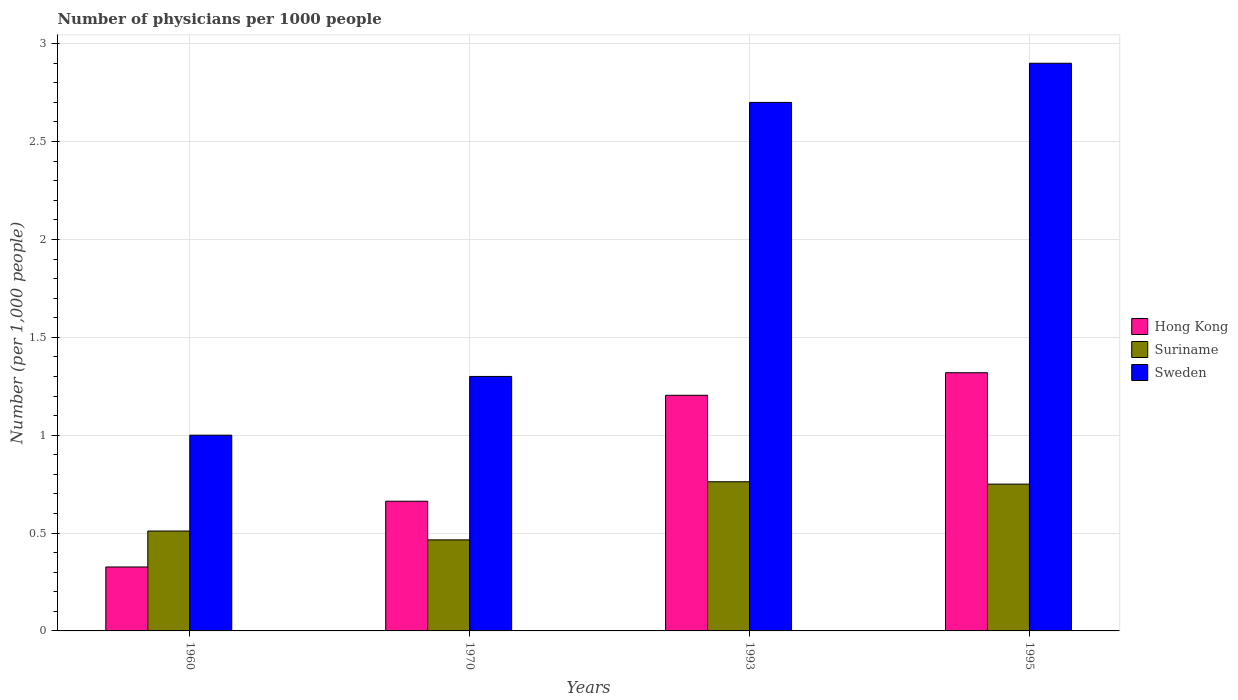How many different coloured bars are there?
Your response must be concise. 3. Are the number of bars on each tick of the X-axis equal?
Keep it short and to the point. Yes. How many bars are there on the 4th tick from the right?
Offer a terse response. 3. What is the number of physicians in Hong Kong in 1995?
Your answer should be compact. 1.32. Across all years, what is the maximum number of physicians in Suriname?
Offer a very short reply. 0.76. Across all years, what is the minimum number of physicians in Suriname?
Your answer should be very brief. 0.47. What is the total number of physicians in Sweden in the graph?
Keep it short and to the point. 7.9. What is the difference between the number of physicians in Hong Kong in 1993 and that in 1995?
Keep it short and to the point. -0.12. What is the difference between the number of physicians in Hong Kong in 1970 and the number of physicians in Sweden in 1960?
Ensure brevity in your answer.  -0.34. What is the average number of physicians in Sweden per year?
Provide a short and direct response. 1.98. In the year 1960, what is the difference between the number of physicians in Sweden and number of physicians in Suriname?
Your response must be concise. 0.49. In how many years, is the number of physicians in Suriname greater than 2.1?
Make the answer very short. 0. What is the ratio of the number of physicians in Hong Kong in 1960 to that in 1993?
Make the answer very short. 0.27. What is the difference between the highest and the second highest number of physicians in Sweden?
Keep it short and to the point. 0.2. What is the difference between the highest and the lowest number of physicians in Hong Kong?
Offer a terse response. 0.99. In how many years, is the number of physicians in Hong Kong greater than the average number of physicians in Hong Kong taken over all years?
Keep it short and to the point. 2. Is the sum of the number of physicians in Suriname in 1970 and 1995 greater than the maximum number of physicians in Hong Kong across all years?
Your answer should be compact. No. What does the 2nd bar from the left in 1993 represents?
Provide a succinct answer. Suriname. What does the 3rd bar from the right in 1970 represents?
Make the answer very short. Hong Kong. Are all the bars in the graph horizontal?
Give a very brief answer. No. Are the values on the major ticks of Y-axis written in scientific E-notation?
Make the answer very short. No. Does the graph contain any zero values?
Your response must be concise. No. Does the graph contain grids?
Offer a terse response. Yes. What is the title of the graph?
Your response must be concise. Number of physicians per 1000 people. Does "Hong Kong" appear as one of the legend labels in the graph?
Give a very brief answer. Yes. What is the label or title of the X-axis?
Offer a terse response. Years. What is the label or title of the Y-axis?
Your response must be concise. Number (per 1,0 people). What is the Number (per 1,000 people) in Hong Kong in 1960?
Provide a short and direct response. 0.33. What is the Number (per 1,000 people) of Suriname in 1960?
Make the answer very short. 0.51. What is the Number (per 1,000 people) of Sweden in 1960?
Offer a very short reply. 1. What is the Number (per 1,000 people) in Hong Kong in 1970?
Your response must be concise. 0.66. What is the Number (per 1,000 people) of Suriname in 1970?
Your answer should be very brief. 0.47. What is the Number (per 1,000 people) of Sweden in 1970?
Offer a very short reply. 1.3. What is the Number (per 1,000 people) in Hong Kong in 1993?
Give a very brief answer. 1.2. What is the Number (per 1,000 people) in Suriname in 1993?
Your response must be concise. 0.76. What is the Number (per 1,000 people) in Sweden in 1993?
Your response must be concise. 2.7. What is the Number (per 1,000 people) of Hong Kong in 1995?
Provide a short and direct response. 1.32. What is the Number (per 1,000 people) of Suriname in 1995?
Your answer should be compact. 0.75. Across all years, what is the maximum Number (per 1,000 people) of Hong Kong?
Give a very brief answer. 1.32. Across all years, what is the maximum Number (per 1,000 people) in Suriname?
Ensure brevity in your answer.  0.76. Across all years, what is the maximum Number (per 1,000 people) of Sweden?
Your answer should be very brief. 2.9. Across all years, what is the minimum Number (per 1,000 people) in Hong Kong?
Your answer should be compact. 0.33. Across all years, what is the minimum Number (per 1,000 people) of Suriname?
Keep it short and to the point. 0.47. What is the total Number (per 1,000 people) of Hong Kong in the graph?
Your answer should be compact. 3.51. What is the total Number (per 1,000 people) of Suriname in the graph?
Provide a short and direct response. 2.49. What is the total Number (per 1,000 people) in Sweden in the graph?
Ensure brevity in your answer.  7.9. What is the difference between the Number (per 1,000 people) in Hong Kong in 1960 and that in 1970?
Make the answer very short. -0.34. What is the difference between the Number (per 1,000 people) of Suriname in 1960 and that in 1970?
Provide a succinct answer. 0.05. What is the difference between the Number (per 1,000 people) in Sweden in 1960 and that in 1970?
Provide a succinct answer. -0.3. What is the difference between the Number (per 1,000 people) in Hong Kong in 1960 and that in 1993?
Give a very brief answer. -0.88. What is the difference between the Number (per 1,000 people) in Suriname in 1960 and that in 1993?
Offer a very short reply. -0.25. What is the difference between the Number (per 1,000 people) in Hong Kong in 1960 and that in 1995?
Offer a very short reply. -0.99. What is the difference between the Number (per 1,000 people) of Suriname in 1960 and that in 1995?
Give a very brief answer. -0.24. What is the difference between the Number (per 1,000 people) of Hong Kong in 1970 and that in 1993?
Ensure brevity in your answer.  -0.54. What is the difference between the Number (per 1,000 people) of Suriname in 1970 and that in 1993?
Provide a short and direct response. -0.3. What is the difference between the Number (per 1,000 people) of Sweden in 1970 and that in 1993?
Give a very brief answer. -1.4. What is the difference between the Number (per 1,000 people) in Hong Kong in 1970 and that in 1995?
Offer a very short reply. -0.66. What is the difference between the Number (per 1,000 people) of Suriname in 1970 and that in 1995?
Your response must be concise. -0.28. What is the difference between the Number (per 1,000 people) of Sweden in 1970 and that in 1995?
Offer a very short reply. -1.6. What is the difference between the Number (per 1,000 people) in Hong Kong in 1993 and that in 1995?
Offer a very short reply. -0.12. What is the difference between the Number (per 1,000 people) in Suriname in 1993 and that in 1995?
Provide a succinct answer. 0.01. What is the difference between the Number (per 1,000 people) in Hong Kong in 1960 and the Number (per 1,000 people) in Suriname in 1970?
Offer a very short reply. -0.14. What is the difference between the Number (per 1,000 people) of Hong Kong in 1960 and the Number (per 1,000 people) of Sweden in 1970?
Your response must be concise. -0.97. What is the difference between the Number (per 1,000 people) in Suriname in 1960 and the Number (per 1,000 people) in Sweden in 1970?
Your response must be concise. -0.79. What is the difference between the Number (per 1,000 people) in Hong Kong in 1960 and the Number (per 1,000 people) in Suriname in 1993?
Your response must be concise. -0.44. What is the difference between the Number (per 1,000 people) in Hong Kong in 1960 and the Number (per 1,000 people) in Sweden in 1993?
Ensure brevity in your answer.  -2.37. What is the difference between the Number (per 1,000 people) of Suriname in 1960 and the Number (per 1,000 people) of Sweden in 1993?
Make the answer very short. -2.19. What is the difference between the Number (per 1,000 people) in Hong Kong in 1960 and the Number (per 1,000 people) in Suriname in 1995?
Ensure brevity in your answer.  -0.42. What is the difference between the Number (per 1,000 people) of Hong Kong in 1960 and the Number (per 1,000 people) of Sweden in 1995?
Offer a terse response. -2.57. What is the difference between the Number (per 1,000 people) of Suriname in 1960 and the Number (per 1,000 people) of Sweden in 1995?
Offer a terse response. -2.39. What is the difference between the Number (per 1,000 people) of Hong Kong in 1970 and the Number (per 1,000 people) of Suriname in 1993?
Provide a short and direct response. -0.1. What is the difference between the Number (per 1,000 people) in Hong Kong in 1970 and the Number (per 1,000 people) in Sweden in 1993?
Keep it short and to the point. -2.04. What is the difference between the Number (per 1,000 people) in Suriname in 1970 and the Number (per 1,000 people) in Sweden in 1993?
Make the answer very short. -2.23. What is the difference between the Number (per 1,000 people) of Hong Kong in 1970 and the Number (per 1,000 people) of Suriname in 1995?
Give a very brief answer. -0.09. What is the difference between the Number (per 1,000 people) of Hong Kong in 1970 and the Number (per 1,000 people) of Sweden in 1995?
Offer a terse response. -2.24. What is the difference between the Number (per 1,000 people) of Suriname in 1970 and the Number (per 1,000 people) of Sweden in 1995?
Your response must be concise. -2.43. What is the difference between the Number (per 1,000 people) in Hong Kong in 1993 and the Number (per 1,000 people) in Suriname in 1995?
Give a very brief answer. 0.45. What is the difference between the Number (per 1,000 people) in Hong Kong in 1993 and the Number (per 1,000 people) in Sweden in 1995?
Offer a very short reply. -1.7. What is the difference between the Number (per 1,000 people) of Suriname in 1993 and the Number (per 1,000 people) of Sweden in 1995?
Offer a terse response. -2.14. What is the average Number (per 1,000 people) in Hong Kong per year?
Offer a terse response. 0.88. What is the average Number (per 1,000 people) of Suriname per year?
Offer a terse response. 0.62. What is the average Number (per 1,000 people) of Sweden per year?
Provide a succinct answer. 1.98. In the year 1960, what is the difference between the Number (per 1,000 people) in Hong Kong and Number (per 1,000 people) in Suriname?
Give a very brief answer. -0.18. In the year 1960, what is the difference between the Number (per 1,000 people) of Hong Kong and Number (per 1,000 people) of Sweden?
Ensure brevity in your answer.  -0.67. In the year 1960, what is the difference between the Number (per 1,000 people) of Suriname and Number (per 1,000 people) of Sweden?
Keep it short and to the point. -0.49. In the year 1970, what is the difference between the Number (per 1,000 people) of Hong Kong and Number (per 1,000 people) of Suriname?
Give a very brief answer. 0.2. In the year 1970, what is the difference between the Number (per 1,000 people) in Hong Kong and Number (per 1,000 people) in Sweden?
Give a very brief answer. -0.64. In the year 1970, what is the difference between the Number (per 1,000 people) in Suriname and Number (per 1,000 people) in Sweden?
Your response must be concise. -0.83. In the year 1993, what is the difference between the Number (per 1,000 people) of Hong Kong and Number (per 1,000 people) of Suriname?
Keep it short and to the point. 0.44. In the year 1993, what is the difference between the Number (per 1,000 people) of Hong Kong and Number (per 1,000 people) of Sweden?
Keep it short and to the point. -1.5. In the year 1993, what is the difference between the Number (per 1,000 people) of Suriname and Number (per 1,000 people) of Sweden?
Offer a very short reply. -1.94. In the year 1995, what is the difference between the Number (per 1,000 people) in Hong Kong and Number (per 1,000 people) in Suriname?
Offer a very short reply. 0.57. In the year 1995, what is the difference between the Number (per 1,000 people) of Hong Kong and Number (per 1,000 people) of Sweden?
Offer a terse response. -1.58. In the year 1995, what is the difference between the Number (per 1,000 people) in Suriname and Number (per 1,000 people) in Sweden?
Keep it short and to the point. -2.15. What is the ratio of the Number (per 1,000 people) of Hong Kong in 1960 to that in 1970?
Offer a very short reply. 0.49. What is the ratio of the Number (per 1,000 people) of Suriname in 1960 to that in 1970?
Provide a short and direct response. 1.1. What is the ratio of the Number (per 1,000 people) in Sweden in 1960 to that in 1970?
Your response must be concise. 0.77. What is the ratio of the Number (per 1,000 people) of Hong Kong in 1960 to that in 1993?
Give a very brief answer. 0.27. What is the ratio of the Number (per 1,000 people) in Suriname in 1960 to that in 1993?
Give a very brief answer. 0.67. What is the ratio of the Number (per 1,000 people) in Sweden in 1960 to that in 1993?
Your answer should be very brief. 0.37. What is the ratio of the Number (per 1,000 people) in Hong Kong in 1960 to that in 1995?
Provide a succinct answer. 0.25. What is the ratio of the Number (per 1,000 people) in Suriname in 1960 to that in 1995?
Your answer should be compact. 0.68. What is the ratio of the Number (per 1,000 people) in Sweden in 1960 to that in 1995?
Your response must be concise. 0.34. What is the ratio of the Number (per 1,000 people) in Hong Kong in 1970 to that in 1993?
Your answer should be very brief. 0.55. What is the ratio of the Number (per 1,000 people) in Suriname in 1970 to that in 1993?
Provide a short and direct response. 0.61. What is the ratio of the Number (per 1,000 people) in Sweden in 1970 to that in 1993?
Ensure brevity in your answer.  0.48. What is the ratio of the Number (per 1,000 people) of Hong Kong in 1970 to that in 1995?
Your answer should be compact. 0.5. What is the ratio of the Number (per 1,000 people) in Suriname in 1970 to that in 1995?
Keep it short and to the point. 0.62. What is the ratio of the Number (per 1,000 people) of Sweden in 1970 to that in 1995?
Provide a short and direct response. 0.45. What is the ratio of the Number (per 1,000 people) of Hong Kong in 1993 to that in 1995?
Make the answer very short. 0.91. What is the ratio of the Number (per 1,000 people) of Sweden in 1993 to that in 1995?
Your response must be concise. 0.93. What is the difference between the highest and the second highest Number (per 1,000 people) of Hong Kong?
Your response must be concise. 0.12. What is the difference between the highest and the second highest Number (per 1,000 people) of Suriname?
Your answer should be compact. 0.01. What is the difference between the highest and the lowest Number (per 1,000 people) of Hong Kong?
Your answer should be compact. 0.99. What is the difference between the highest and the lowest Number (per 1,000 people) in Suriname?
Your answer should be compact. 0.3. What is the difference between the highest and the lowest Number (per 1,000 people) of Sweden?
Your answer should be compact. 1.9. 